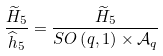<formula> <loc_0><loc_0><loc_500><loc_500>\frac { \widetilde { H } _ { 5 } } { \widehat { h } _ { 5 } } = \frac { \widetilde { H } _ { 5 } } { S O \left ( q , 1 \right ) \times \mathcal { A } _ { q } }</formula> 